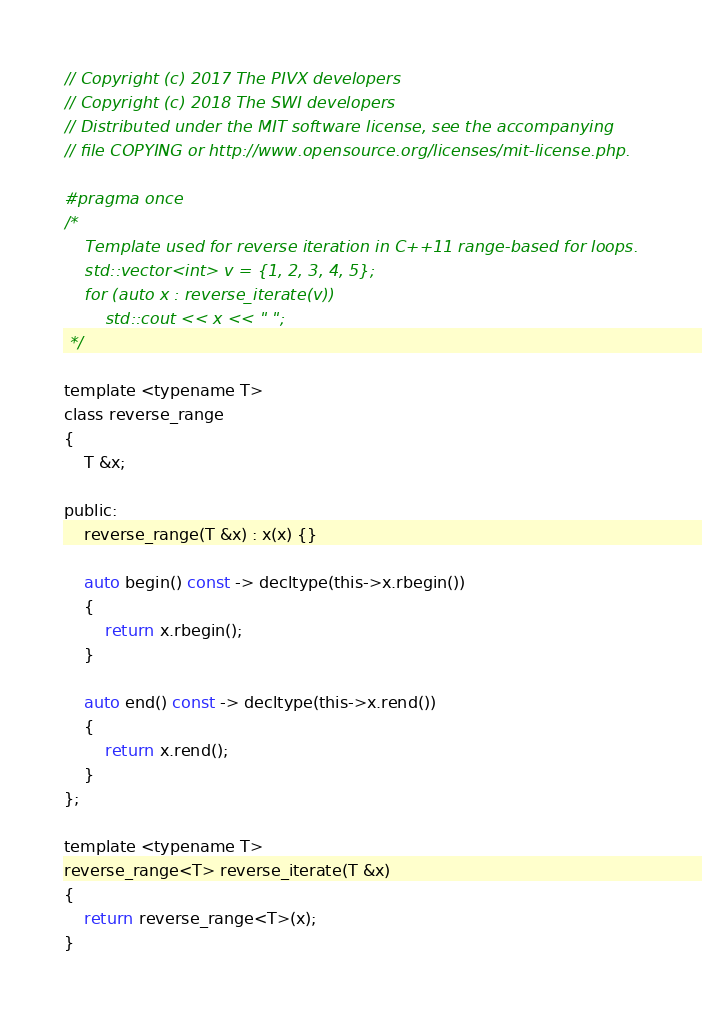Convert code to text. <code><loc_0><loc_0><loc_500><loc_500><_C_>// Copyright (c) 2017 The PIVX developers
// Copyright (c) 2018 The SWI developers
// Distributed under the MIT software license, see the accompanying
// file COPYING or http://www.opensource.org/licenses/mit-license.php.

#pragma once
/*
    Template used for reverse iteration in C++11 range-based for loops.
    std::vector<int> v = {1, 2, 3, 4, 5};
    for (auto x : reverse_iterate(v))
        std::cout << x << " ";
 */

template <typename T>
class reverse_range
{
    T &x;
    
public:
    reverse_range(T &x) : x(x) {}
    
    auto begin() const -> decltype(this->x.rbegin())
    {
        return x.rbegin();
    }
    
    auto end() const -> decltype(this->x.rend())
    {
        return x.rend();
    }
};
 
template <typename T>
reverse_range<T> reverse_iterate(T &x)
{
    return reverse_range<T>(x);
}

</code> 